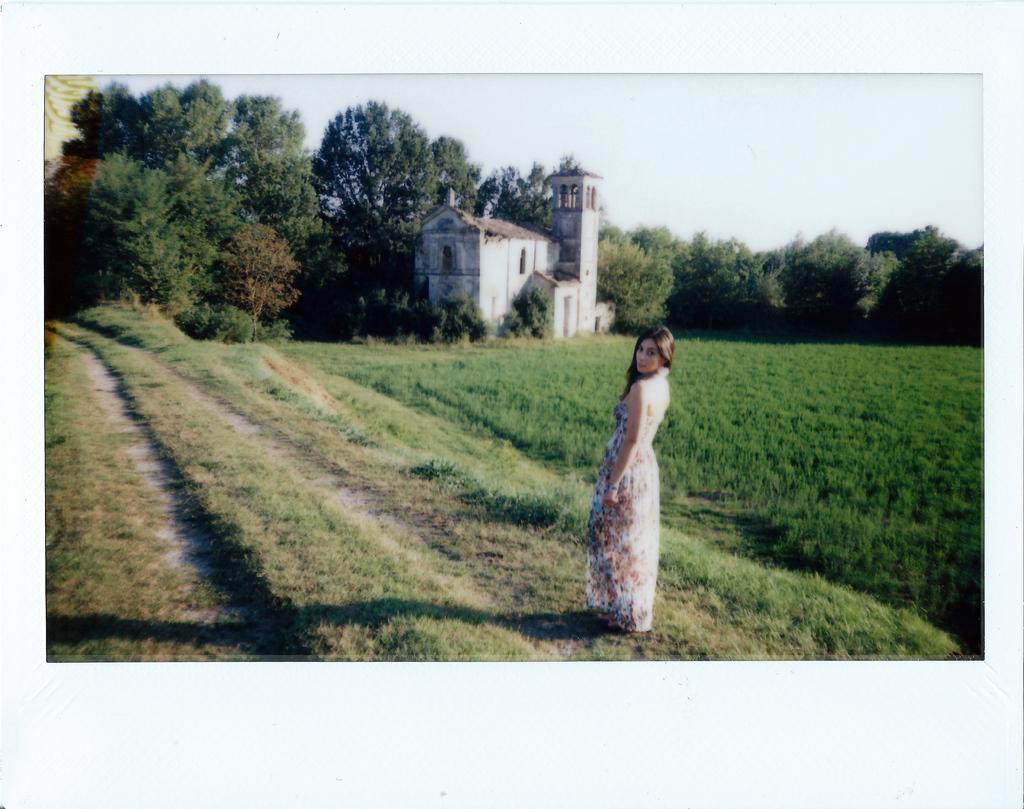How would you summarize this image in a sentence or two? In the center of the image we can see a person is standing and she is in a different costume. In the background, we can see the sky, trees, one building and grass. 